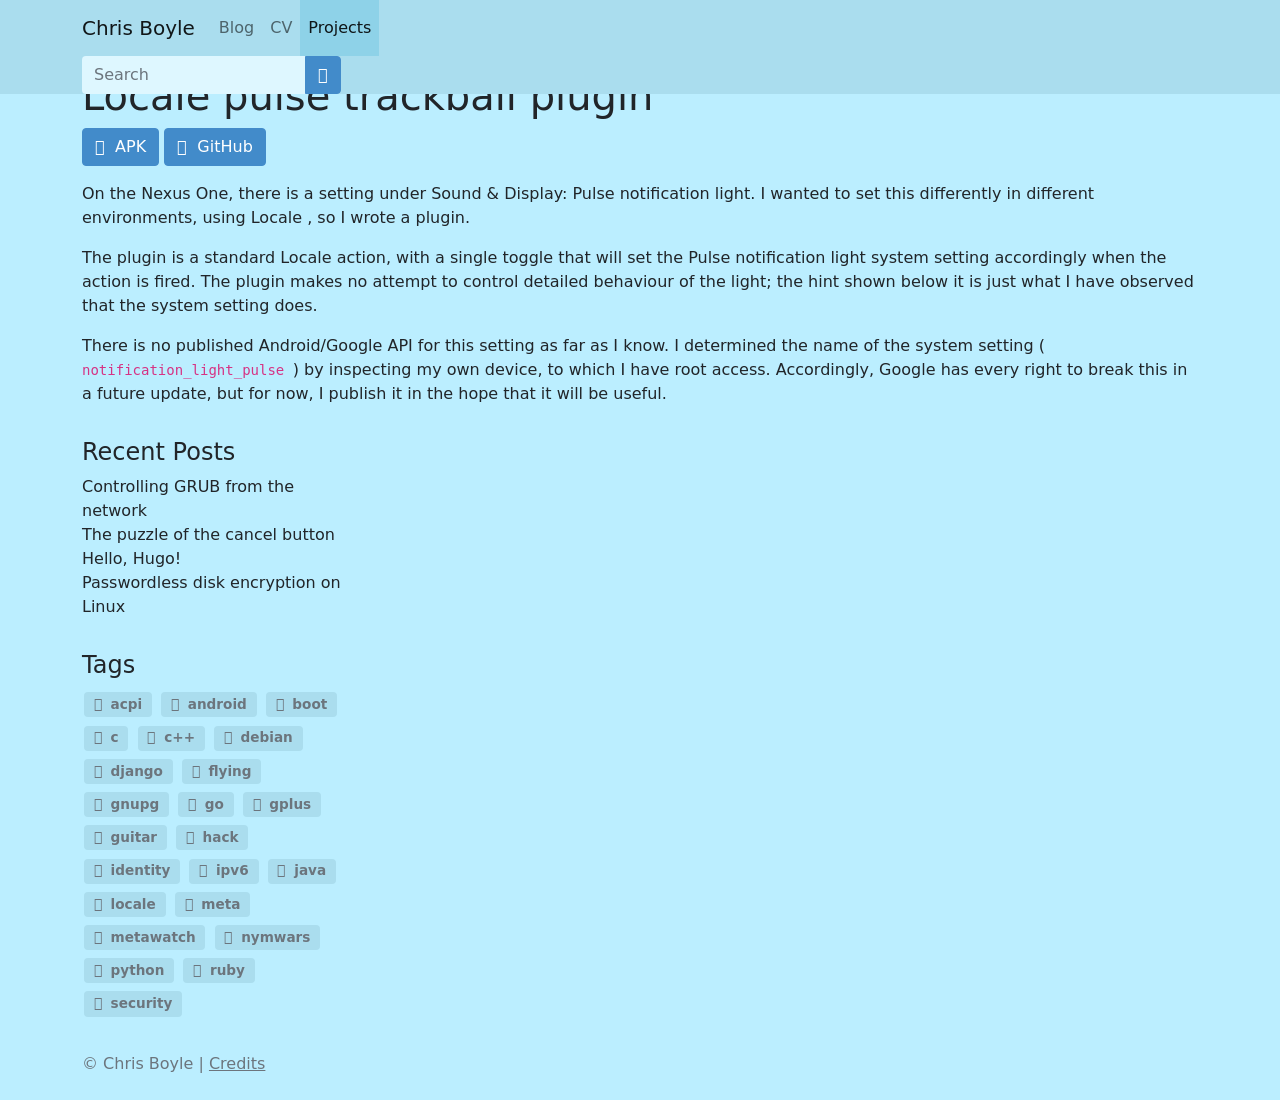What's the procedure for constructing this website from scratch with HTML? To construct a website from scratch using HTML, start by defining the basic structure with HTML tags. First, create a document type and html tag to encapsulate all content. You’d then need a head tag, which contains meta tags for SEO, links to CSS for styling, and the page title. Inside the body tag, you can establish the structural layout of your webpage using header, nav, main, aside, and footer tags which help organize the content. You would also add content within these, such as text in paragraphs (p tags), links (a tags), and images (img tags). Here’s a simple example:

<!DOCTYPE html>
<html>
<head>
    <title>My First Website</title>
</head>
<body>
    <header>
        <h1>Welcome to My Website</h1>
    </header>
    <nav>
        <ul>
            <li><a href="#home">Home</a></li>
            <li><a href="#services">Services</a></li>
            <li><a href="#about">About</a></li>
        </ul>
    </nav>
    <main>
        <section>
            <h2>About Us</h2>
            <p>This is a paragraph about our company.</p>
        </section>
    </main>
    <footer>
        <p>Contact us at email@example.com</p>
    </footer>
</body>
</html>

This structure forms the skeleton of your website, onto which you can build more complex features and style with CSS and enhance interactivity with JavaScript. 